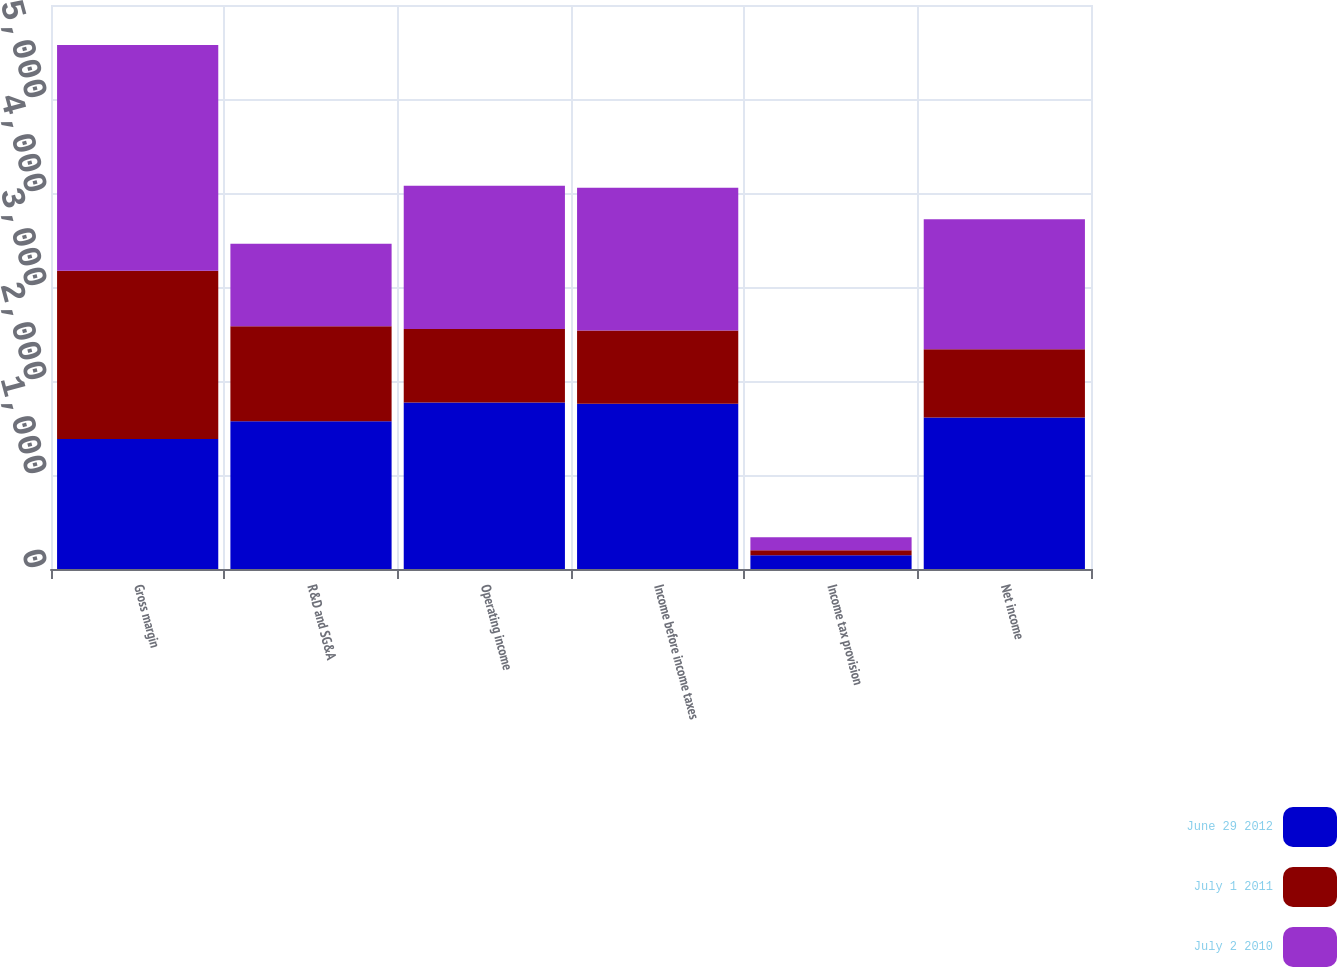Convert chart. <chart><loc_0><loc_0><loc_500><loc_500><stacked_bar_chart><ecel><fcel>Gross margin<fcel>R&D and SG&A<fcel>Operating income<fcel>Income before income taxes<fcel>Income tax provision<fcel>Net income<nl><fcel>June 29 2012<fcel>1382<fcel>1573<fcel>1771<fcel>1757<fcel>145<fcel>1612<nl><fcel>July 1 2011<fcel>1791<fcel>1010<fcel>781<fcel>780<fcel>54<fcel>726<nl><fcel>July 2 2010<fcel>2401<fcel>876<fcel>1525<fcel>1520<fcel>138<fcel>1382<nl></chart> 